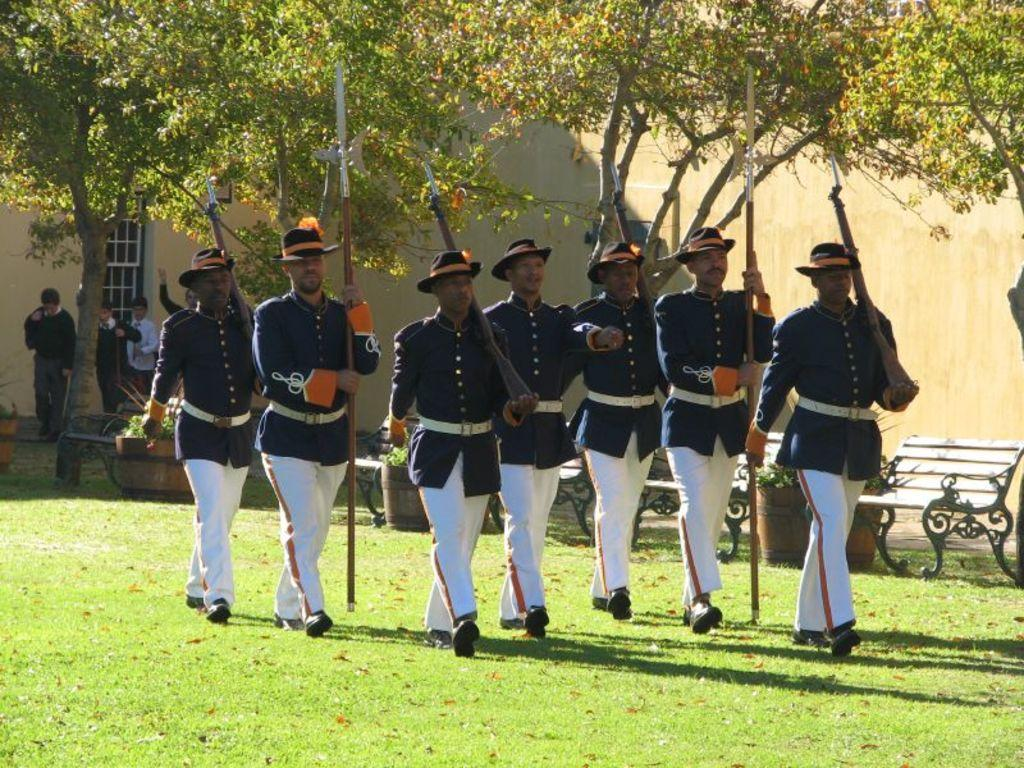What are the people in the image doing? The people in the image are walking. What are the people holding while walking? The people are holding sticks. What type of natural environment is visible in the image? There are trees, grass, and benches in the image. What type of bomb can be seen in the image? There is no bomb present in the image. Can you tell me the credit score of the person sitting on the bench in the image? There is no information about credit scores or personal finances in the image. 